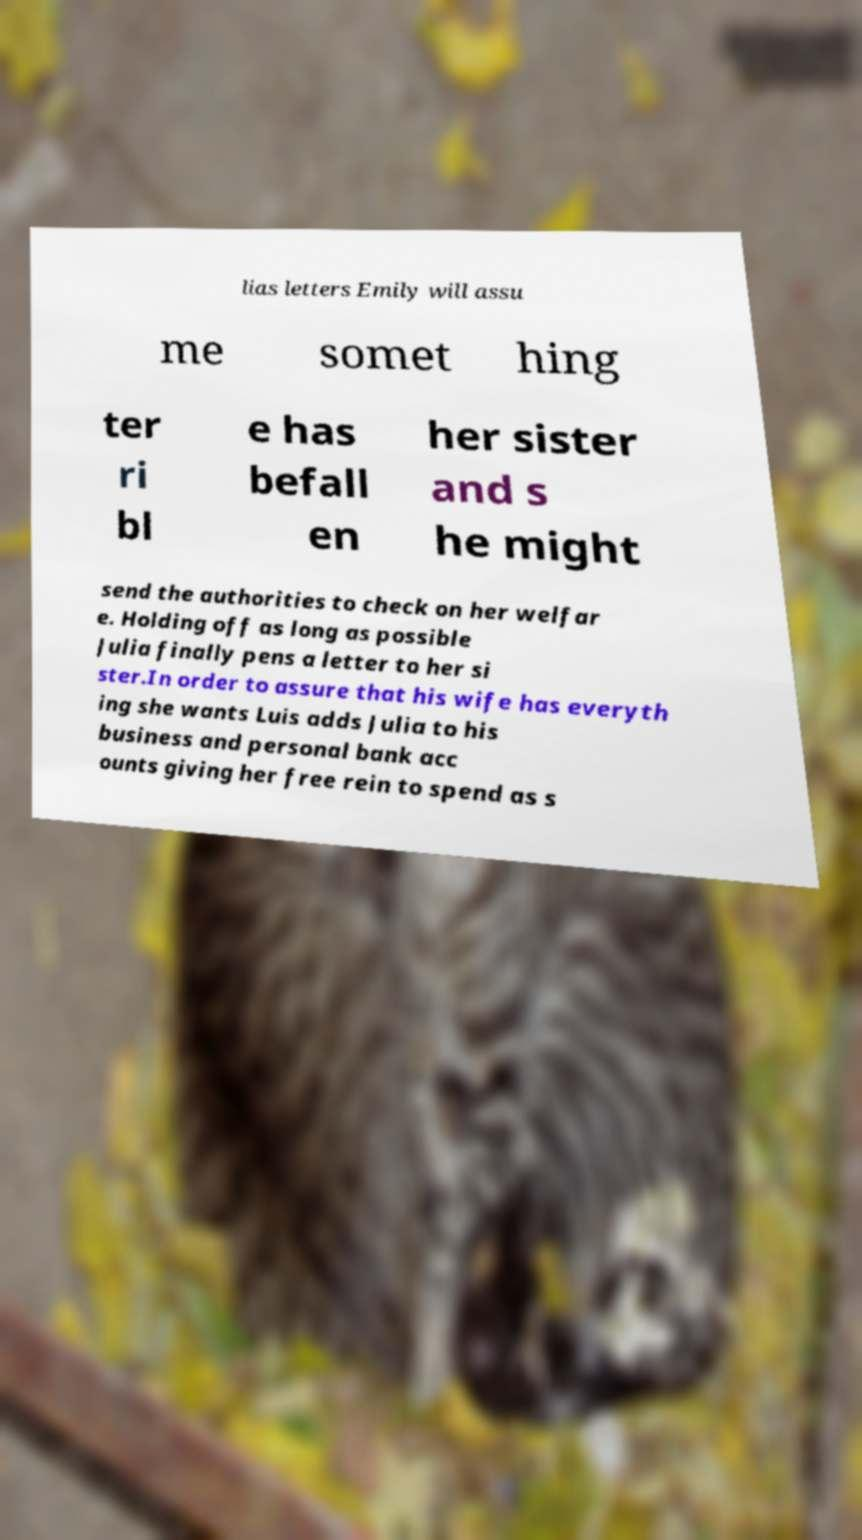Can you read and provide the text displayed in the image?This photo seems to have some interesting text. Can you extract and type it out for me? lias letters Emily will assu me somet hing ter ri bl e has befall en her sister and s he might send the authorities to check on her welfar e. Holding off as long as possible Julia finally pens a letter to her si ster.In order to assure that his wife has everyth ing she wants Luis adds Julia to his business and personal bank acc ounts giving her free rein to spend as s 